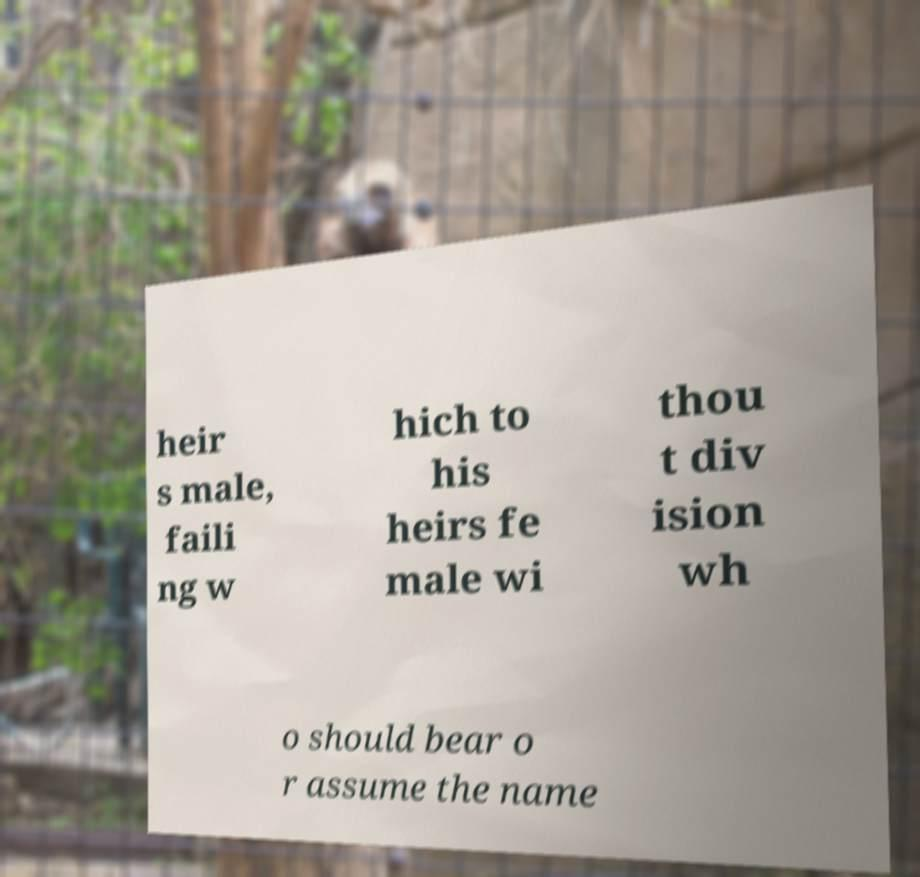What messages or text are displayed in this image? I need them in a readable, typed format. heir s male, faili ng w hich to his heirs fe male wi thou t div ision wh o should bear o r assume the name 